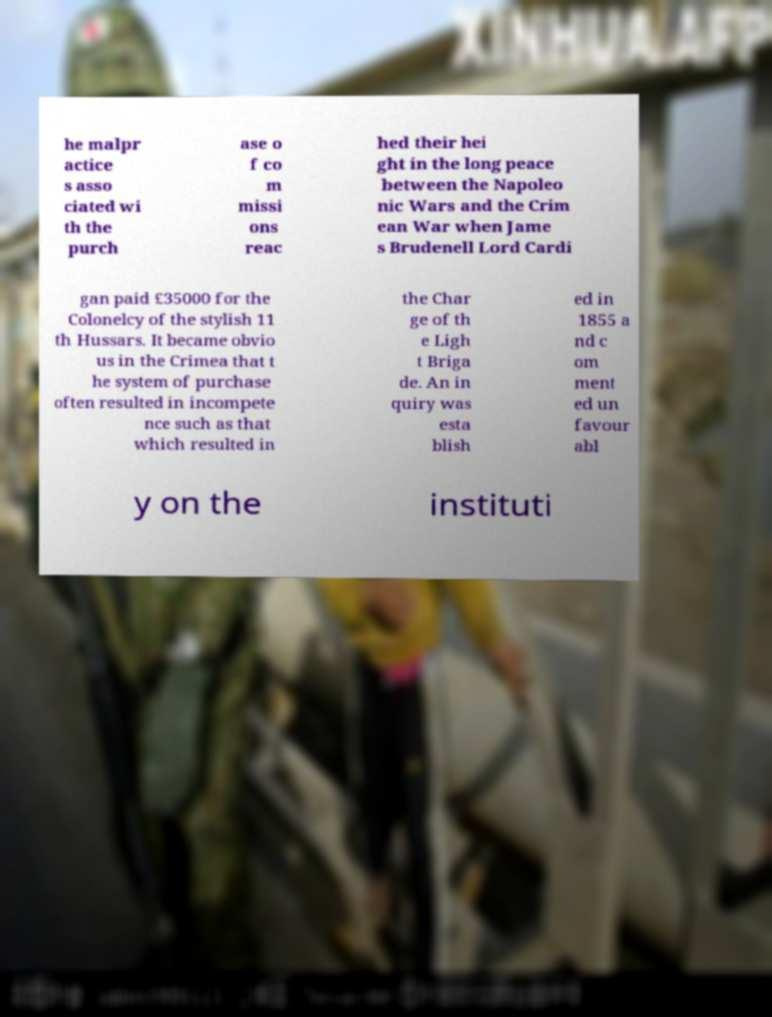There's text embedded in this image that I need extracted. Can you transcribe it verbatim? he malpr actice s asso ciated wi th the purch ase o f co m missi ons reac hed their hei ght in the long peace between the Napoleo nic Wars and the Crim ean War when Jame s Brudenell Lord Cardi gan paid £35000 for the Colonelcy of the stylish 11 th Hussars. It became obvio us in the Crimea that t he system of purchase often resulted in incompete nce such as that which resulted in the Char ge of th e Ligh t Briga de. An in quiry was esta blish ed in 1855 a nd c om ment ed un favour abl y on the instituti 